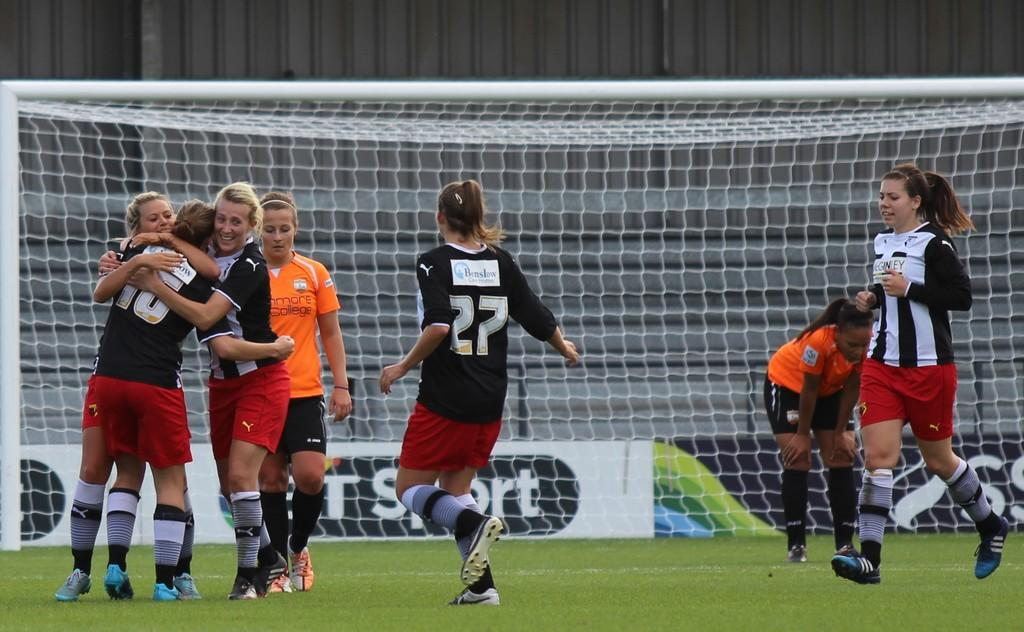<image>
Give a short and clear explanation of the subsequent image. Two teams of young girls including player number 27 are playing a soccer match. 